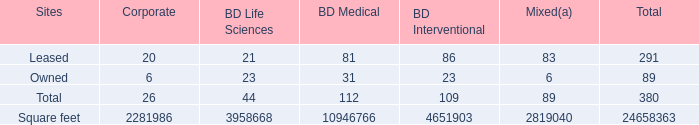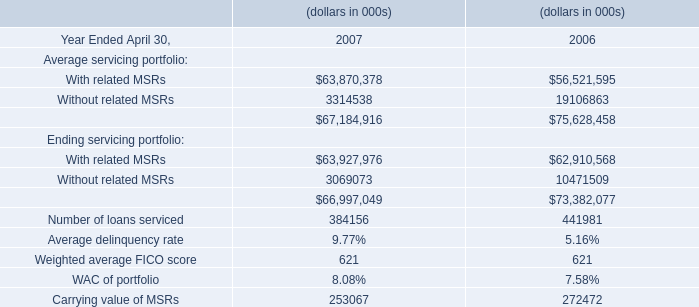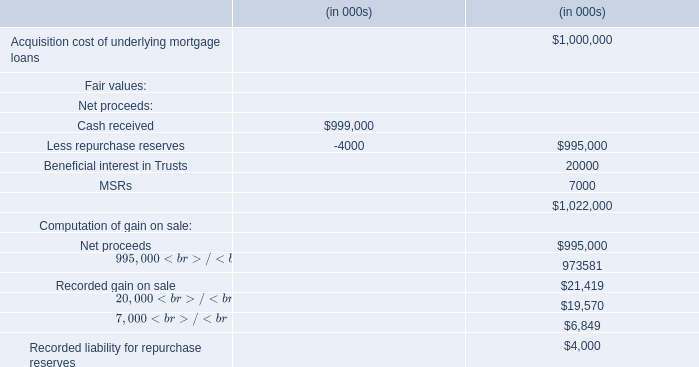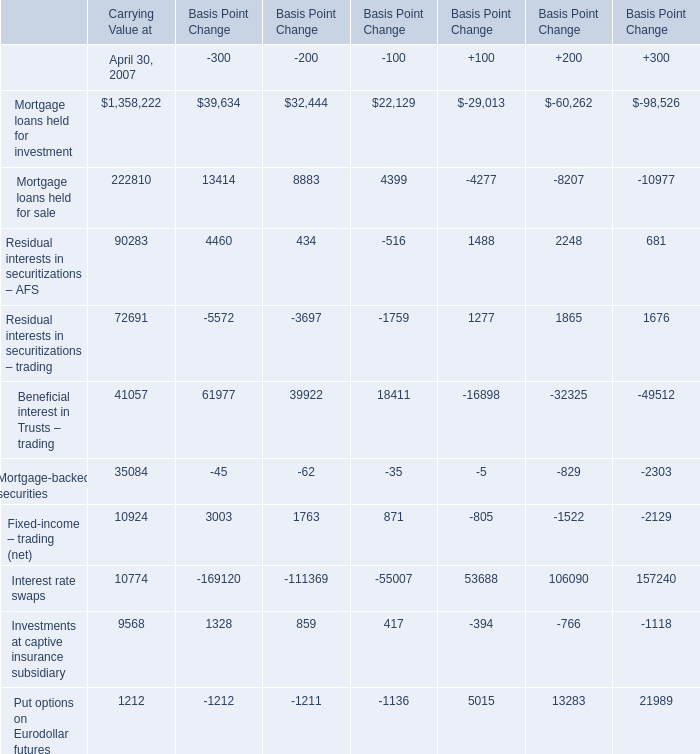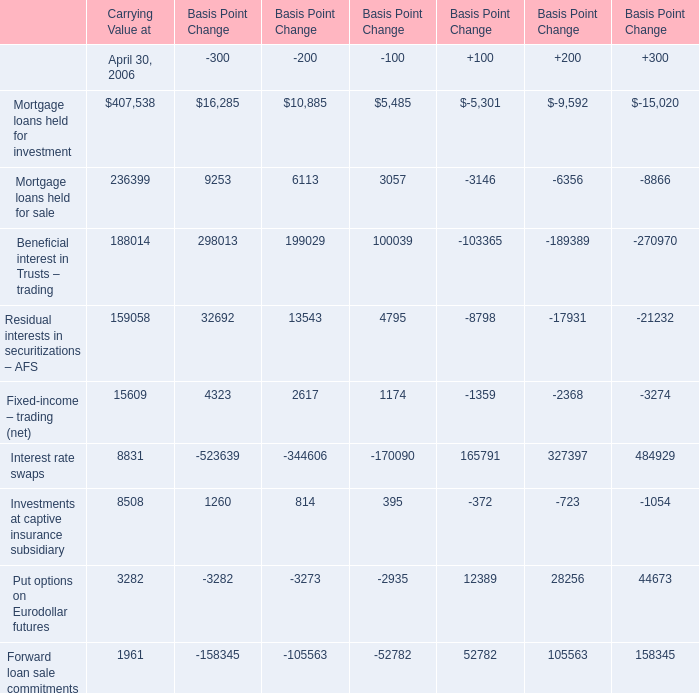What is the sum of Mortgage loans held for investment,Mortgage loans held for sale and Residual interests in securitizations – AFS in 2007 for Carrying Value? 
Computations: ((1358222 + 222810) + 90283)
Answer: 1671315.0. 